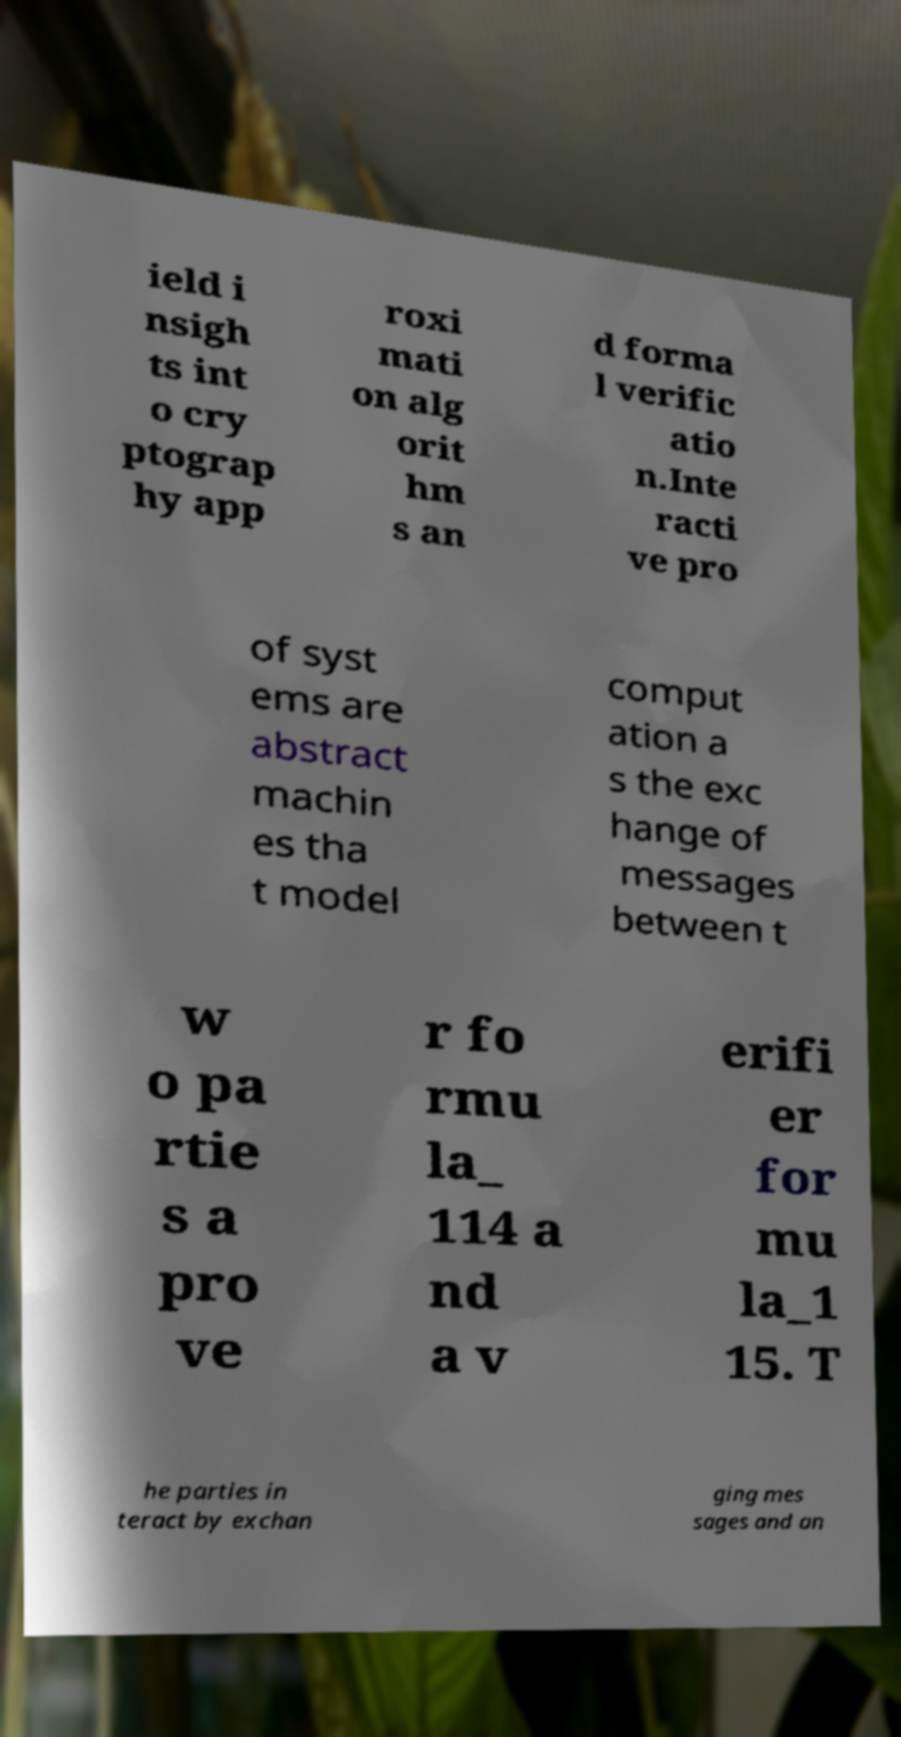Please read and relay the text visible in this image. What does it say? ield i nsigh ts int o cry ptograp hy app roxi mati on alg orit hm s an d forma l verific atio n.Inte racti ve pro of syst ems are abstract machin es tha t model comput ation a s the exc hange of messages between t w o pa rtie s a pro ve r fo rmu la_ 114 a nd a v erifi er for mu la_1 15. T he parties in teract by exchan ging mes sages and an 